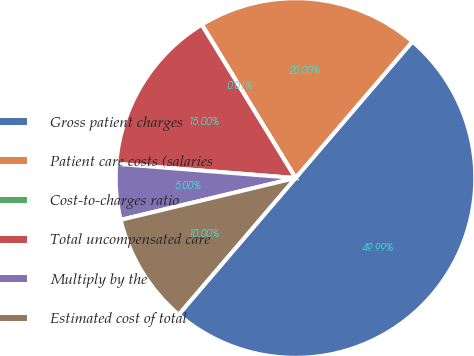<chart> <loc_0><loc_0><loc_500><loc_500><pie_chart><fcel>Gross patient charges<fcel>Patient care costs (salaries<fcel>Cost-to-charges ratio<fcel>Total uncompensated care<fcel>Multiply by the<fcel>Estimated cost of total<nl><fcel>49.99%<fcel>20.0%<fcel>0.01%<fcel>15.0%<fcel>5.0%<fcel>10.0%<nl></chart> 